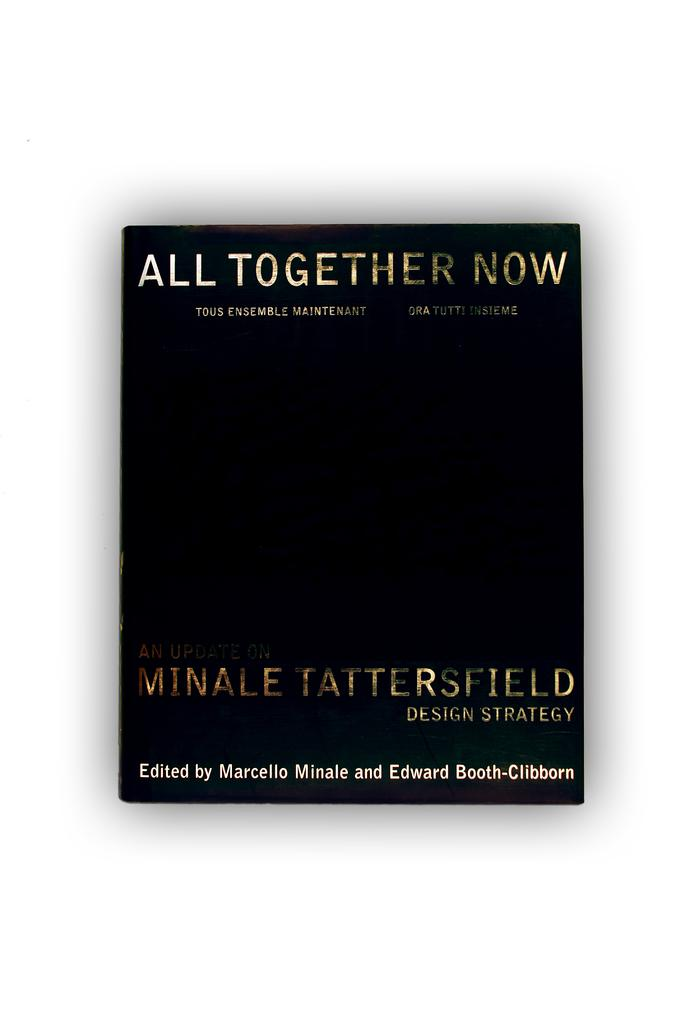<image>
Render a clear and concise summary of the photo. A book about design strategy is titled All Together Now. 